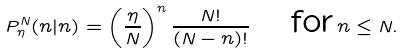<formula> <loc_0><loc_0><loc_500><loc_500>P ^ { N } _ { \eta } ( n | n ) = \left ( \frac { \eta } { N } \right ) ^ { n } \frac { N ! } { ( N - n ) ! } \quad \text {for} \, n \leq N .</formula> 